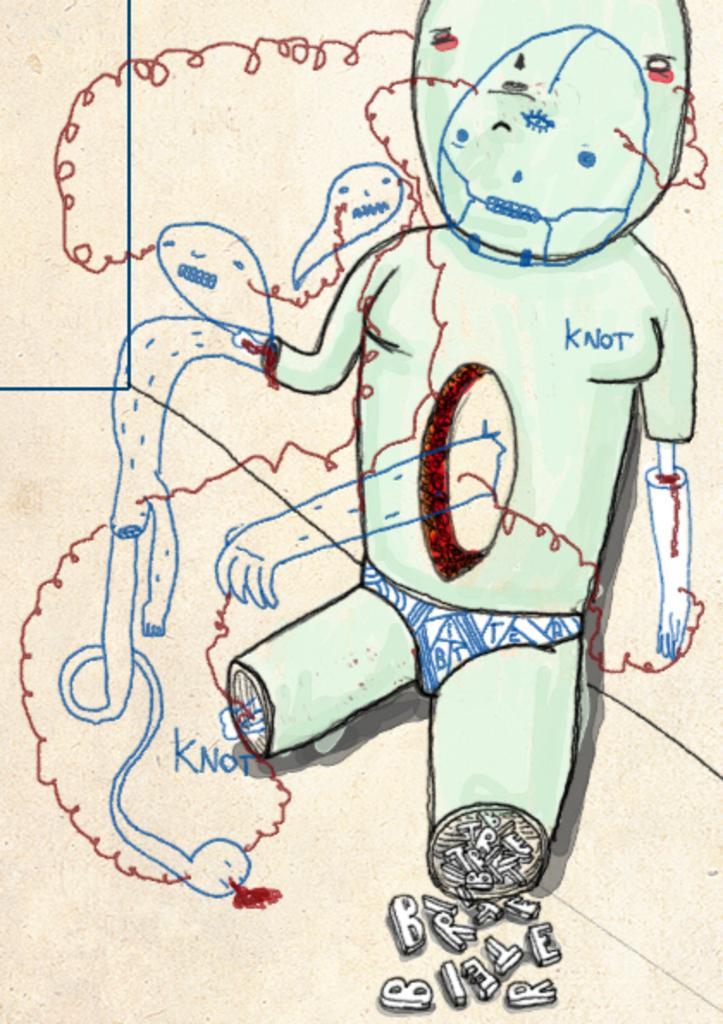Please provide a concise description of this image. In this image I can see an art of a person and the background is in white color and I can see something written on the paper. 